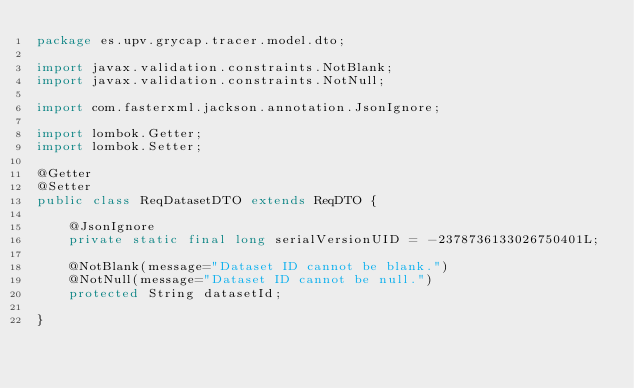<code> <loc_0><loc_0><loc_500><loc_500><_Java_>package es.upv.grycap.tracer.model.dto;

import javax.validation.constraints.NotBlank;
import javax.validation.constraints.NotNull;

import com.fasterxml.jackson.annotation.JsonIgnore;

import lombok.Getter;
import lombok.Setter;

@Getter
@Setter
public class ReqDatasetDTO extends ReqDTO {

	@JsonIgnore
	private static final long serialVersionUID = -2378736133026750401L;
	
	@NotBlank(message="Dataset ID cannot be blank.")
	@NotNull(message="Dataset ID cannot be null.")
	protected String datasetId;

}
</code> 